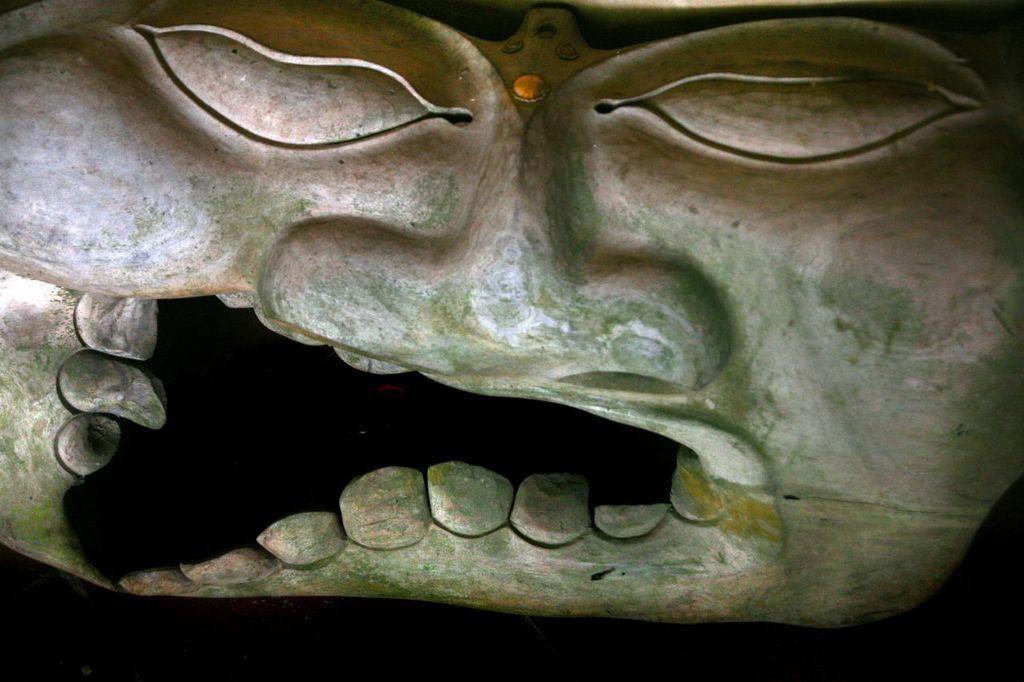Can you describe this image briefly? In the center of this picture we can see an object seems to be the sculpture of the face of a person. The background of the image is black in color. 